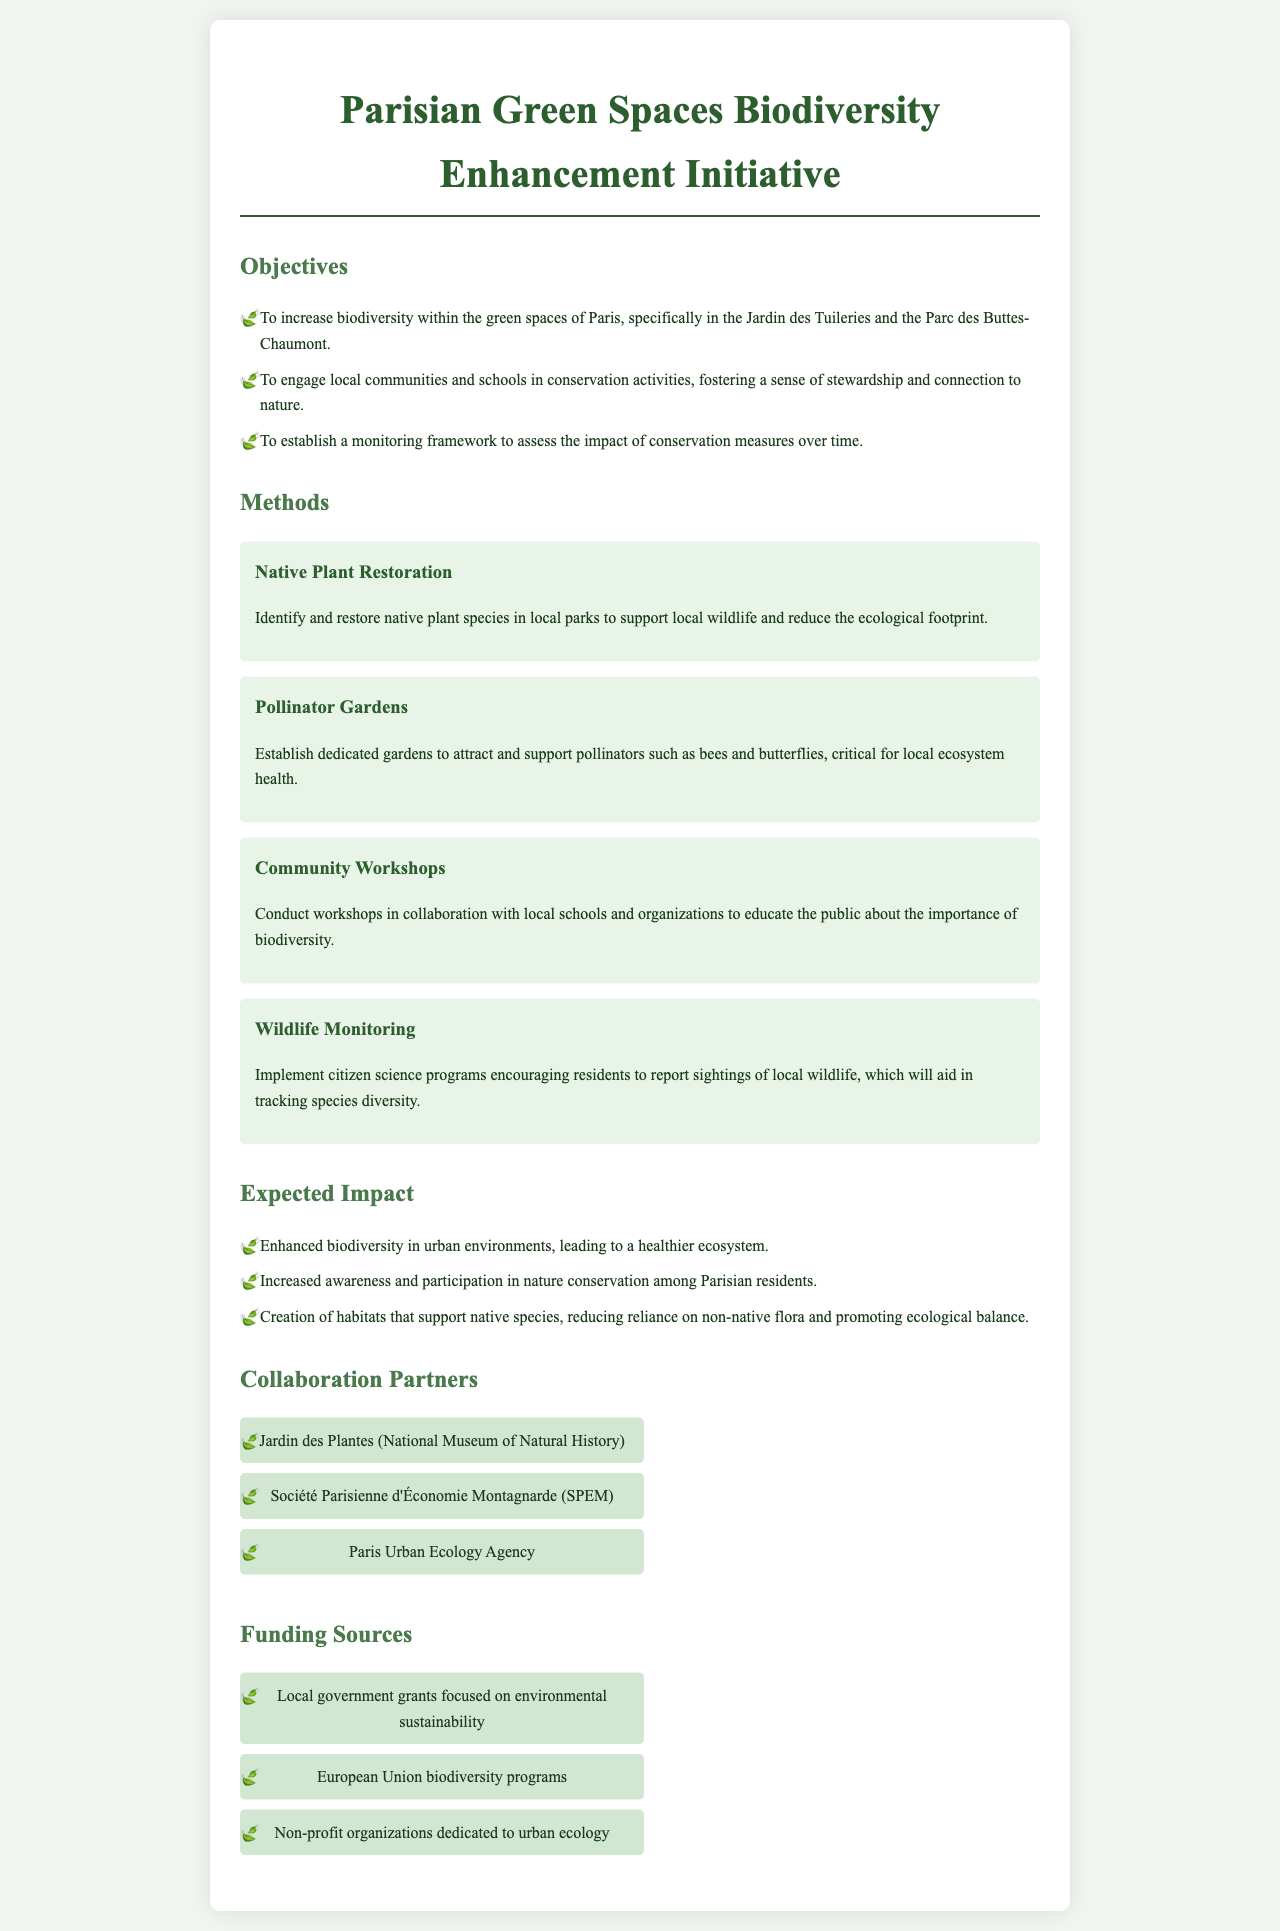What is the title of the initiative? The title of the initiative is found at the top of the document.
Answer: Parisian Green Spaces Biodiversity Enhancement Initiative Which two green spaces are primarily targeted for biodiversity enhancement? The specific green spaces are mentioned in the objectives section.
Answer: Jardin des Tuileries and Parc des Buttes-Chaumont What method focuses on attracting pollinators? The method is outlined in the methods section and explicitly mentions pollinators.
Answer: Pollinator Gardens How many main objectives are listed in the proposal? The total is given in the objectives section where each is clearly enumerated.
Answer: Three Which organization is listed as a collaboration partner? The collaboration partners are provided in a dedicated section of the document.
Answer: Jardin des Plantes (National Museum of Natural History) What is expected to increase among Parisian residents due to the initiative? The expected impact section discusses the anticipated change in community involvement.
Answer: Awareness and participation in nature conservation How many funding sources are mentioned? The funding sources are detailed in a list which can be counted.
Answer: Three What type of workshops will be conducted? The method section explains the nature of the workshops being proposed.
Answer: Community Workshops 